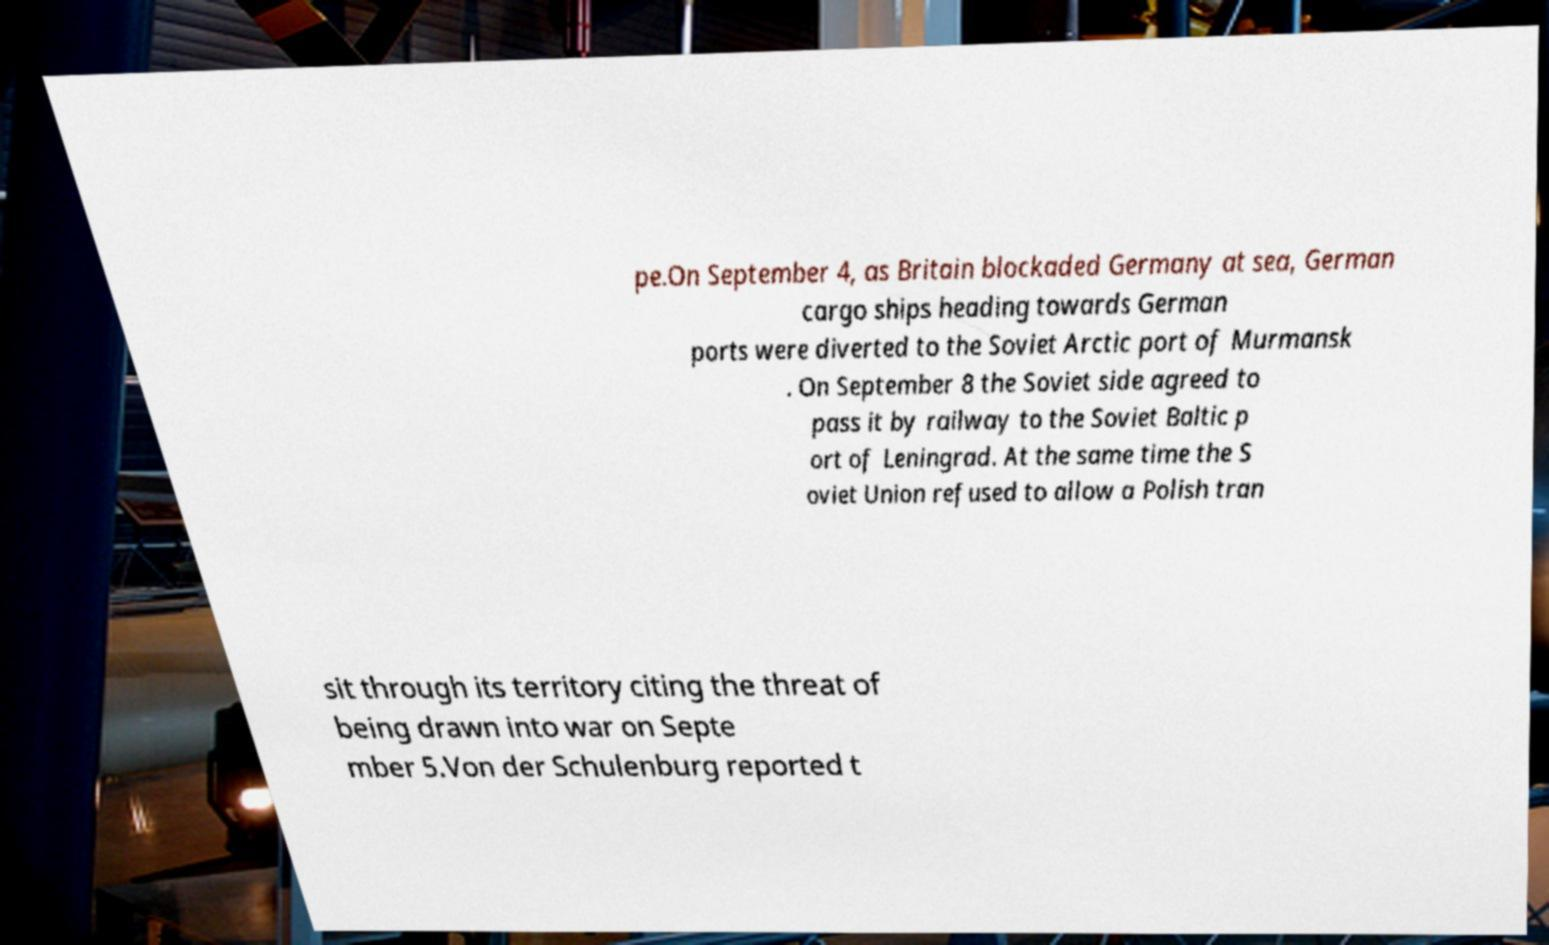For documentation purposes, I need the text within this image transcribed. Could you provide that? pe.On September 4, as Britain blockaded Germany at sea, German cargo ships heading towards German ports were diverted to the Soviet Arctic port of Murmansk . On September 8 the Soviet side agreed to pass it by railway to the Soviet Baltic p ort of Leningrad. At the same time the S oviet Union refused to allow a Polish tran sit through its territory citing the threat of being drawn into war on Septe mber 5.Von der Schulenburg reported t 